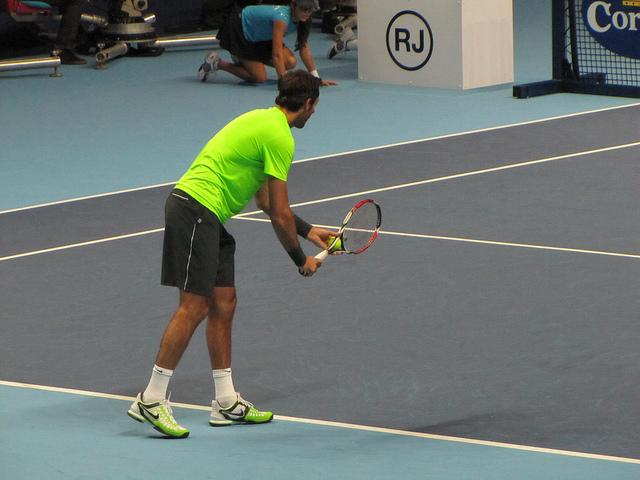What is the job of the girl who is knelt down in the front of the picture? ball girl 